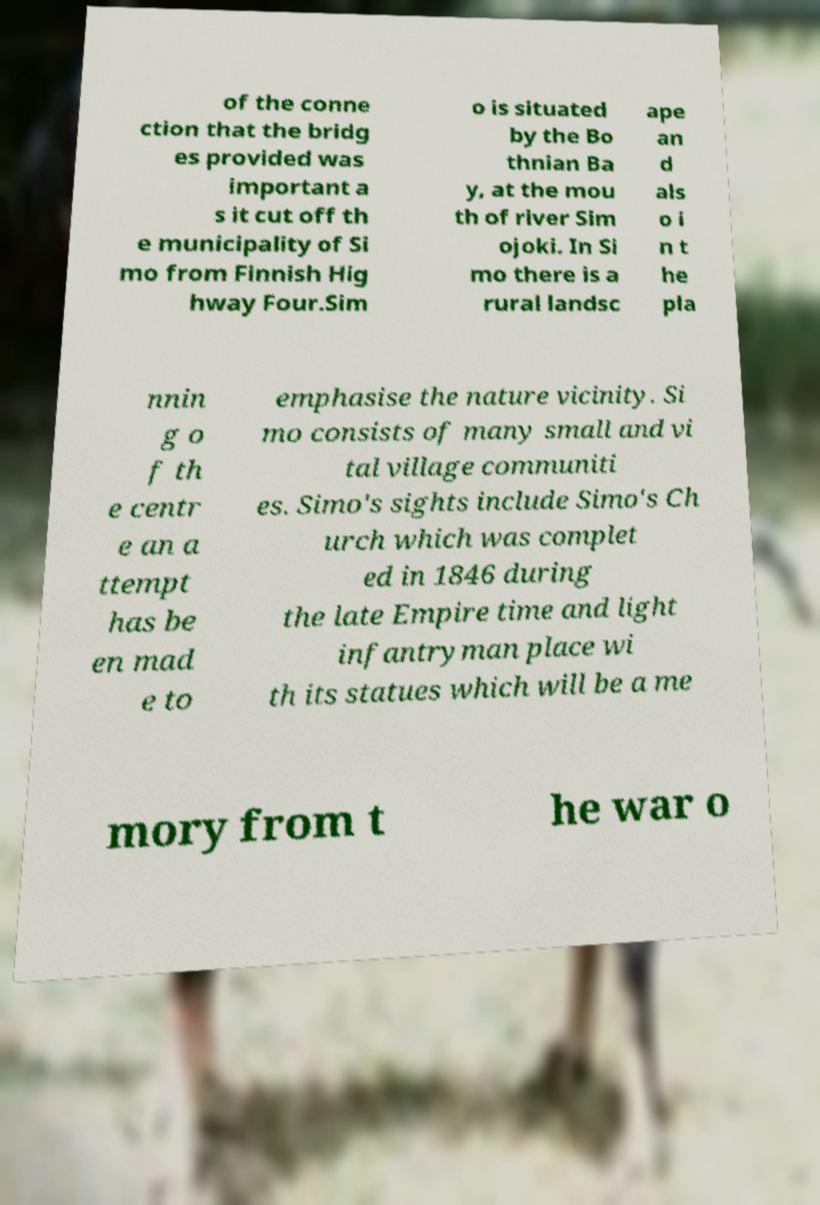Can you read and provide the text displayed in the image?This photo seems to have some interesting text. Can you extract and type it out for me? of the conne ction that the bridg es provided was important a s it cut off th e municipality of Si mo from Finnish Hig hway Four.Sim o is situated by the Bo thnian Ba y, at the mou th of river Sim ojoki. In Si mo there is a rural landsc ape an d als o i n t he pla nnin g o f th e centr e an a ttempt has be en mad e to emphasise the nature vicinity. Si mo consists of many small and vi tal village communiti es. Simo's sights include Simo's Ch urch which was complet ed in 1846 during the late Empire time and light infantryman place wi th its statues which will be a me mory from t he war o 